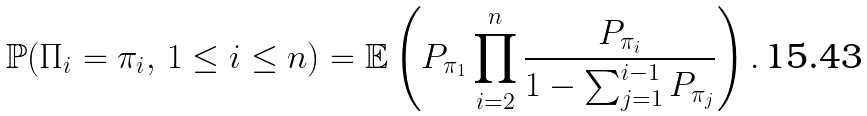Convert formula to latex. <formula><loc_0><loc_0><loc_500><loc_500>\mathbb { P } ( \Pi _ { i } = \pi _ { i } , \, 1 \leq i \leq n ) = \mathbb { E } \left ( P _ { \pi _ { 1 } } \prod _ { i = 2 } ^ { n } \frac { P _ { \pi _ { i } } } { 1 - \sum _ { j = 1 } ^ { i - 1 } P _ { \pi _ { j } } } \right ) .</formula> 